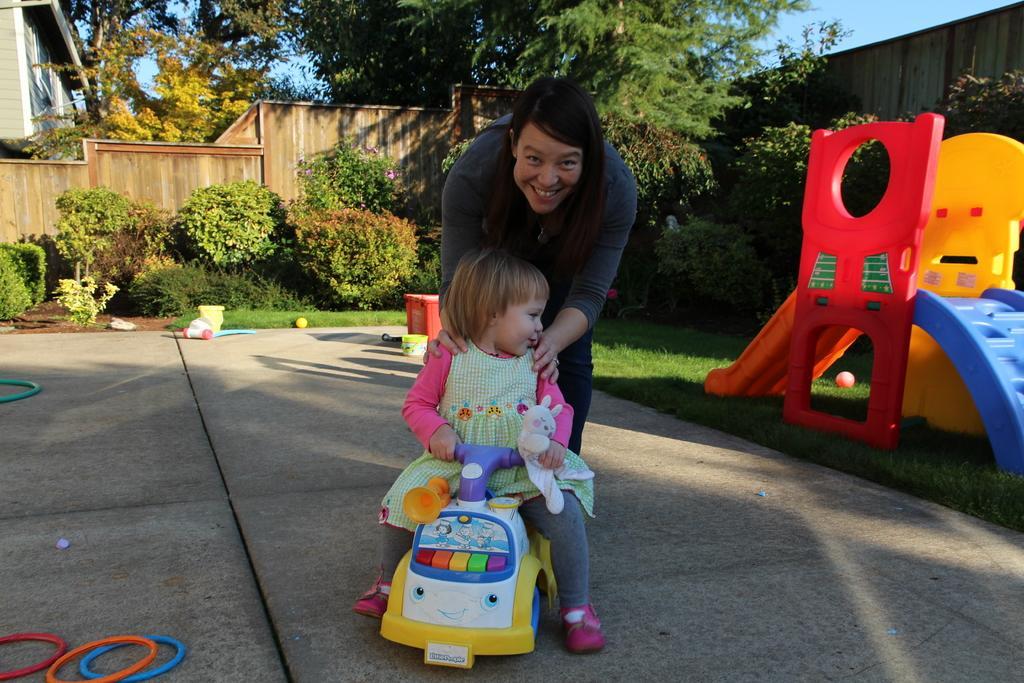How would you summarize this image in a sentence or two? In this picture there is a woman smiling, in front of her there is a girl sitting on a toy vehicle and we can see tennikoit rings, slide, balls and objects. We can see grass, plants, flowers, wall, house and trees. In the background of the image we can see the sky. 